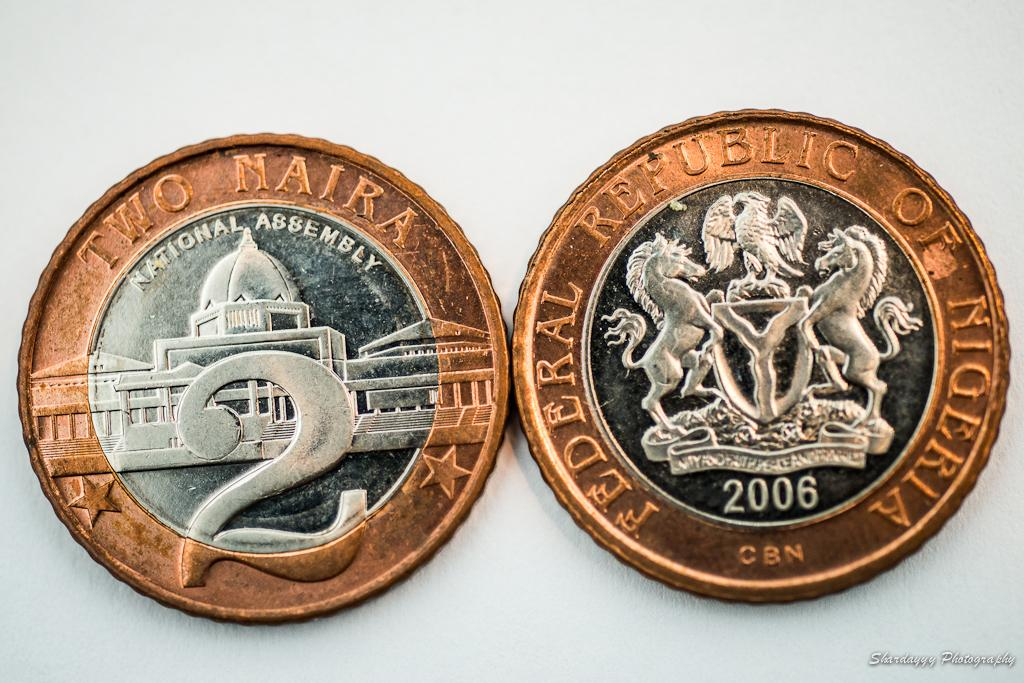Provide a one-sentence caption for the provided image. Two coins are adjacent to each other with one including the text National Assembly. 